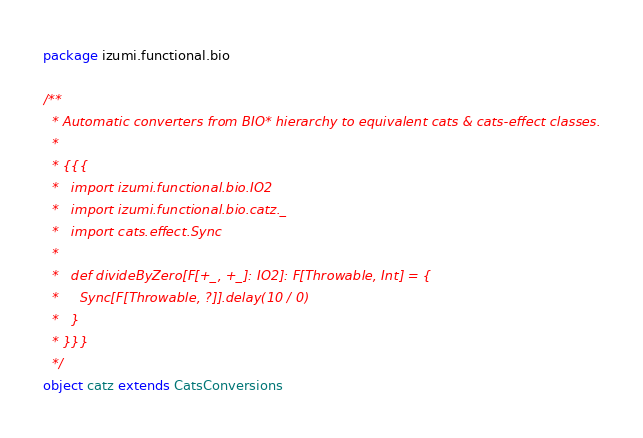Convert code to text. <code><loc_0><loc_0><loc_500><loc_500><_Scala_>package izumi.functional.bio

/**
  * Automatic converters from BIO* hierarchy to equivalent cats & cats-effect classes.
  *
  * {{{
  *   import izumi.functional.bio.IO2
  *   import izumi.functional.bio.catz._
  *   import cats.effect.Sync
  *
  *   def divideByZero[F[+_, +_]: IO2]: F[Throwable, Int] = {
  *     Sync[F[Throwable, ?]].delay(10 / 0)
  *   }
  * }}}
  */
object catz extends CatsConversions
</code> 